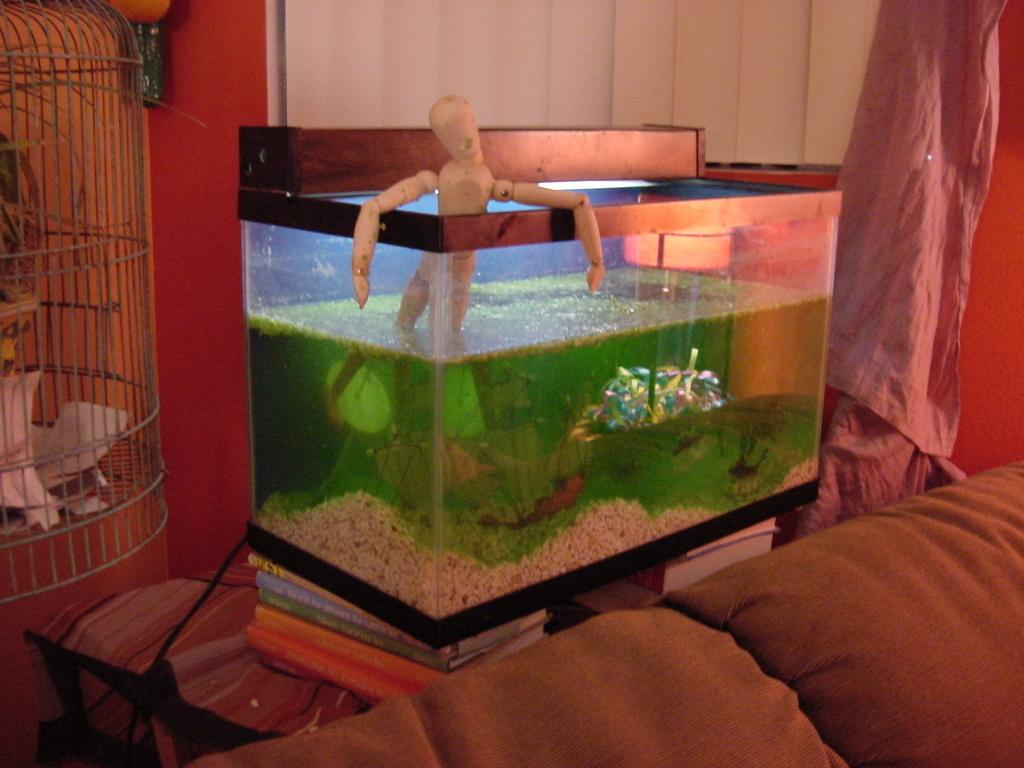What type of furniture is in the image? There is a sofa in the image. What is located behind the sofa? There is an aquarium behind the sofa. What is situated beside the aquarium? There is a cage beside the aquarium. What can be seen in the background of the image? There is a wall and a curtain in the background of the image. How many frogs are sitting on the guide in the image? There is no guide or frogs present in the image. 